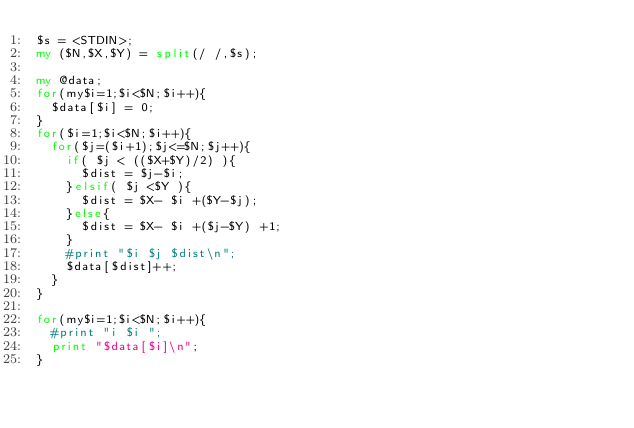<code> <loc_0><loc_0><loc_500><loc_500><_Perl_>$s = <STDIN>;
my ($N,$X,$Y) = split(/ /,$s);

my @data;
for(my$i=1;$i<$N;$i++){
  $data[$i] = 0;
}
for($i=1;$i<$N;$i++){
  for($j=($i+1);$j<=$N;$j++){
    if( $j < (($X+$Y)/2) ){
      $dist = $j-$i;
    }elsif( $j <$Y ){
      $dist = $X- $i +($Y-$j);
    }else{
      $dist = $X- $i +($j-$Y) +1;
    }
    #print "$i $j $dist\n";
    $data[$dist]++;
  }
}

for(my$i=1;$i<$N;$i++){
  #print "i $i ";
  print "$data[$i]\n";
}</code> 